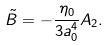<formula> <loc_0><loc_0><loc_500><loc_500>\tilde { B } = - { \frac { \eta _ { 0 } } { 3 a _ { 0 } ^ { 4 } } } A _ { 2 } .</formula> 